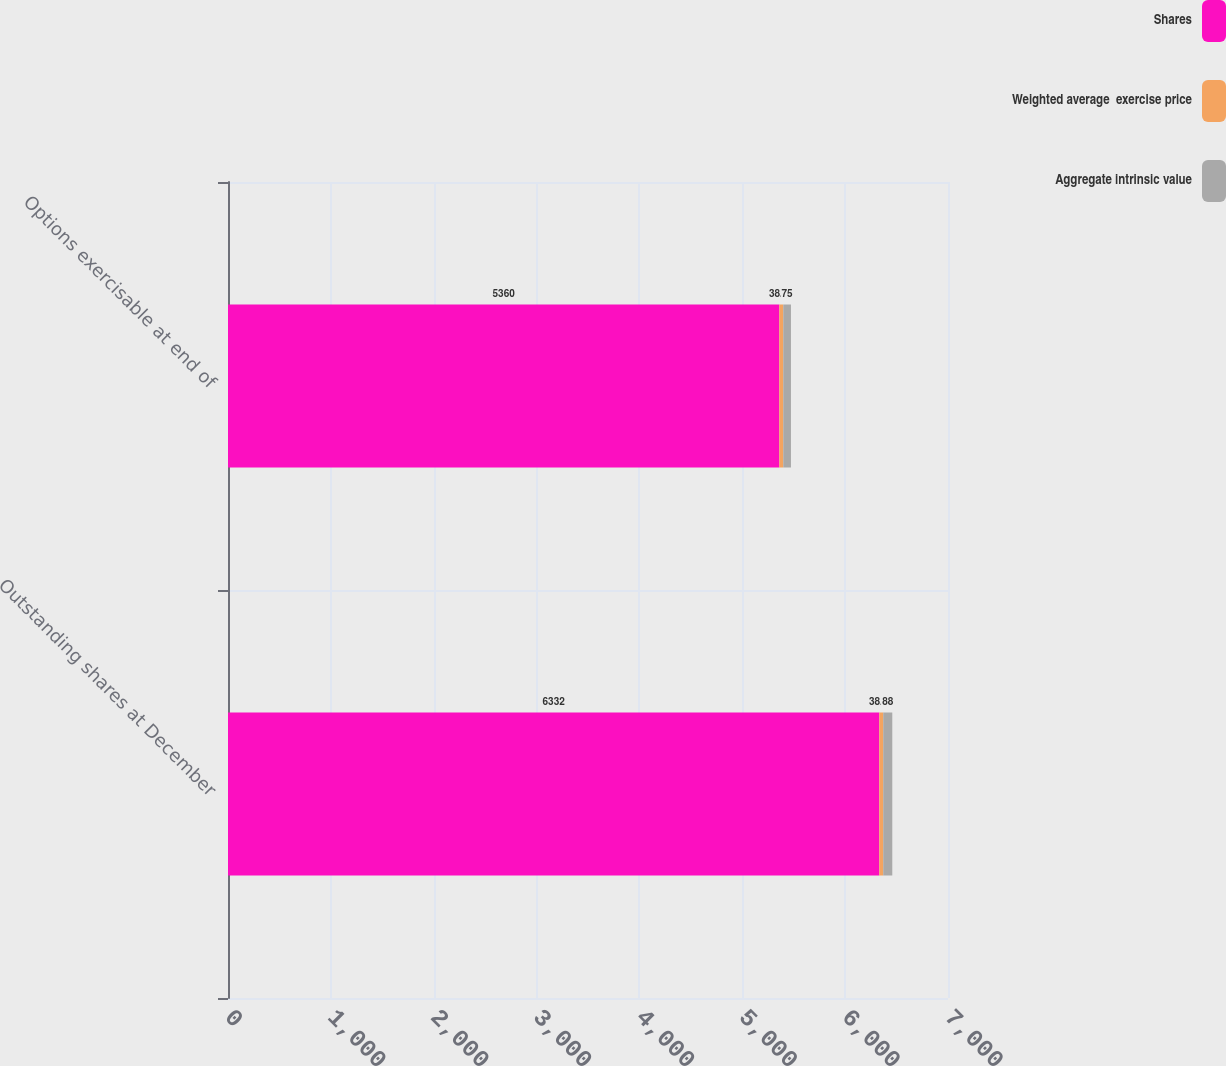Convert chart. <chart><loc_0><loc_0><loc_500><loc_500><stacked_bar_chart><ecel><fcel>Outstanding shares at December<fcel>Options exercisable at end of<nl><fcel>Shares<fcel>6332<fcel>5360<nl><fcel>Weighted average  exercise price<fcel>38.39<fcel>38.33<nl><fcel>Aggregate intrinsic value<fcel>88<fcel>75<nl></chart> 